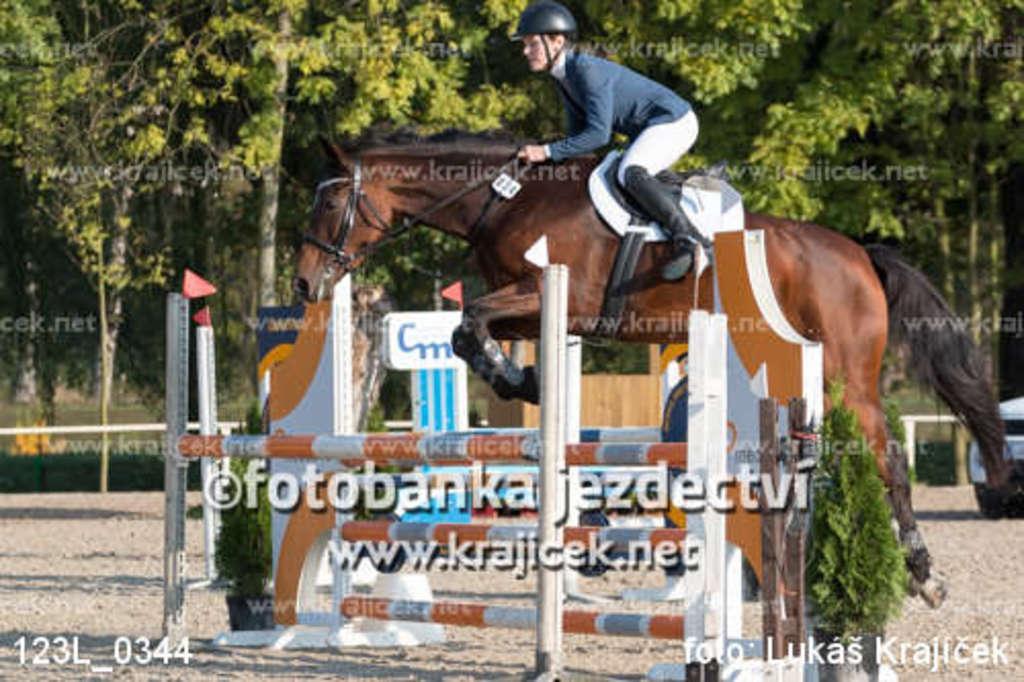Can you describe this image briefly? In this Image I see a person who is on the horse and there are plants. In the background I see the trees. 